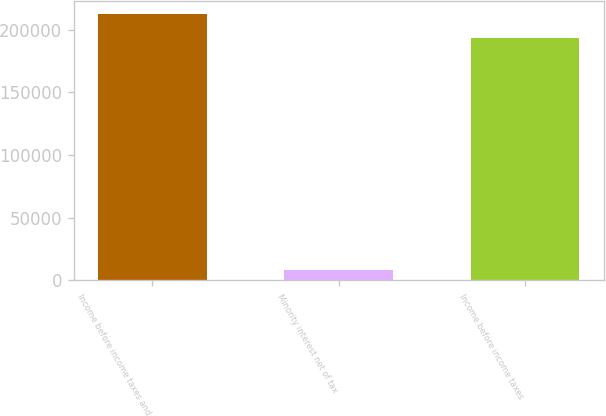Convert chart. <chart><loc_0><loc_0><loc_500><loc_500><bar_chart><fcel>Income before income taxes and<fcel>Minority interest net of tax<fcel>Income before income taxes<nl><fcel>212351<fcel>8474<fcel>193046<nl></chart> 